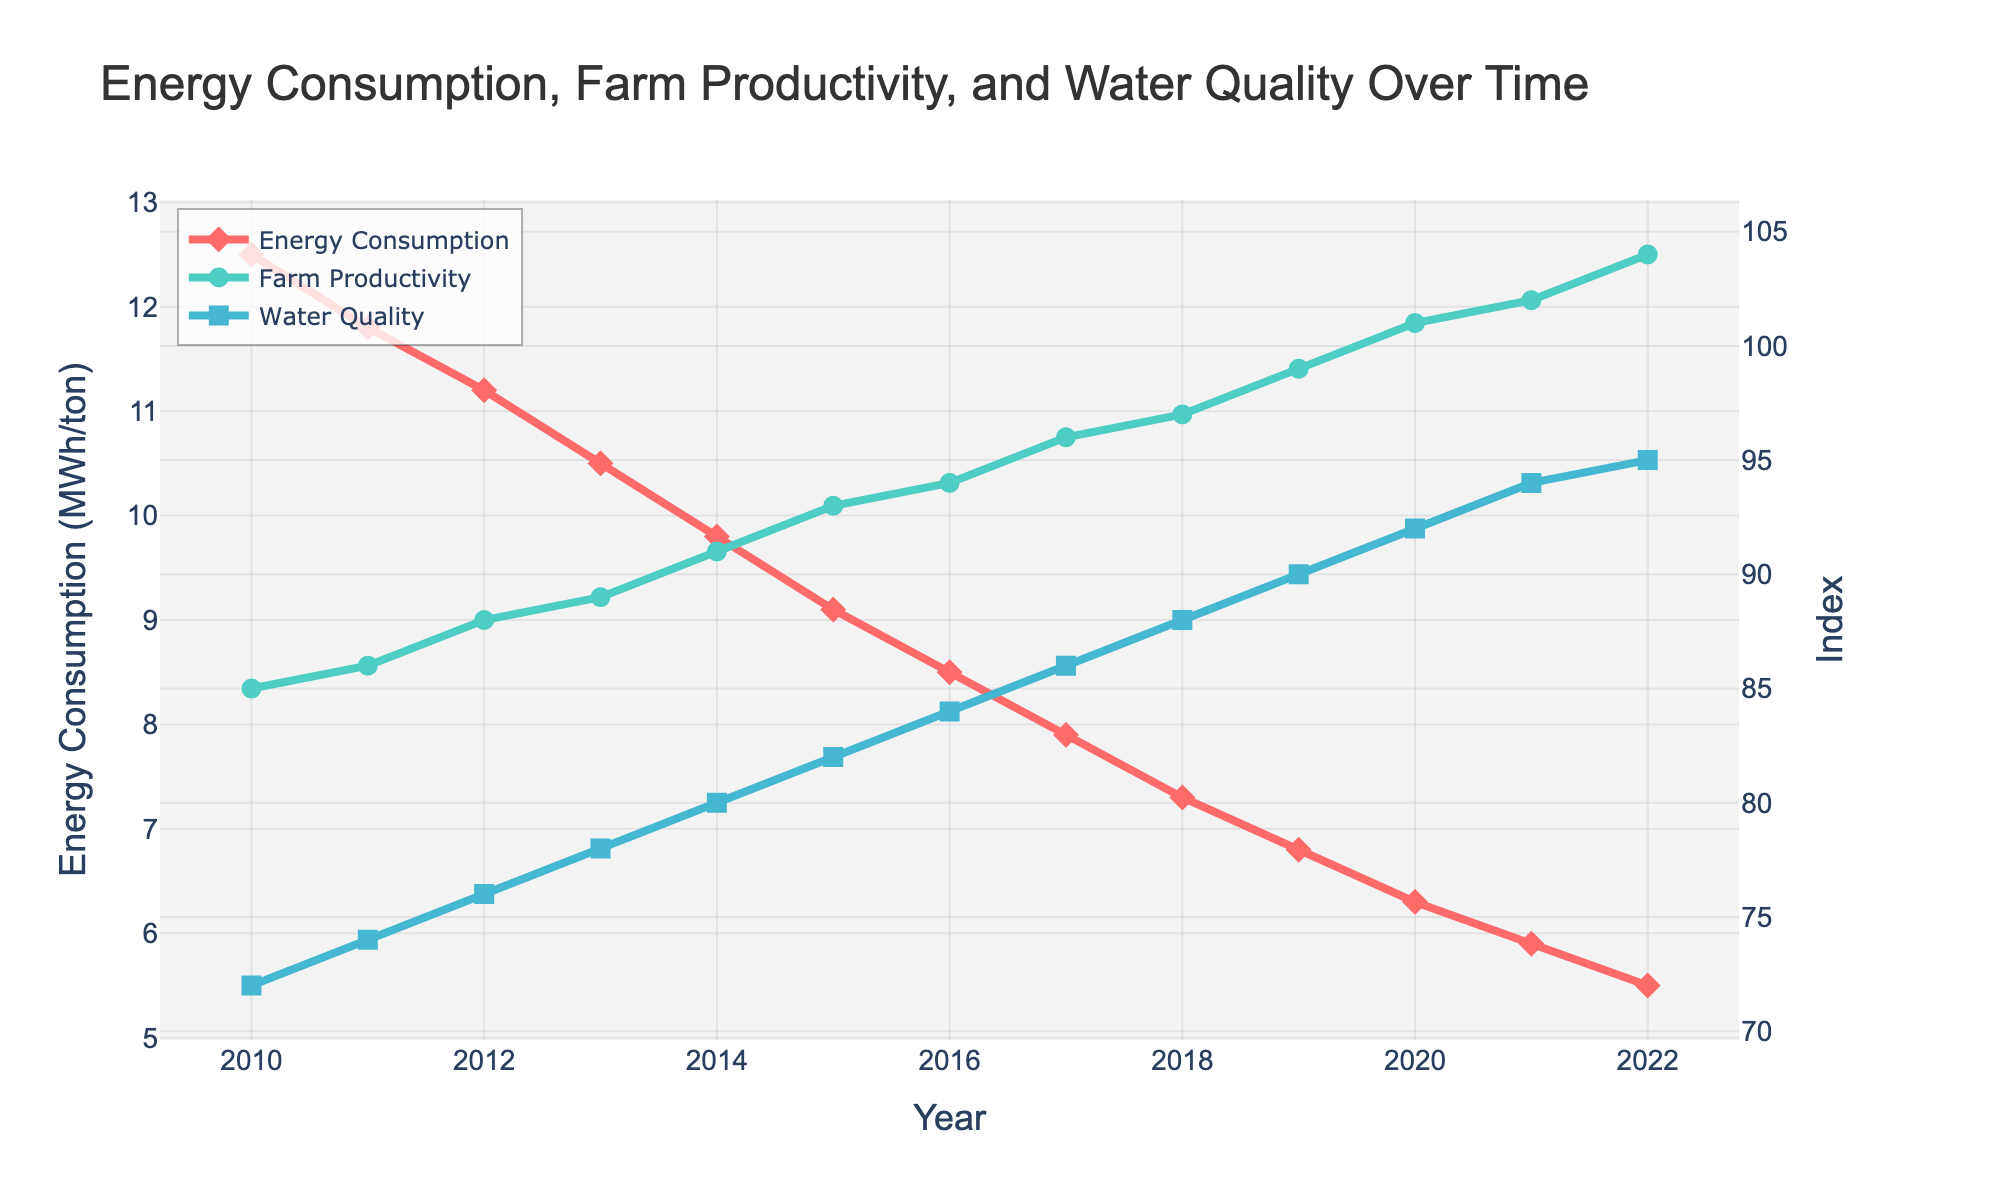What trend do you observe in energy consumption from 2010 to 2022? The energy consumption in MWh per ton decreases steadily from 12.5 in 2010 to 5.5 in 2022. A consistent downward trend is visible.
Answer: A consistent decrease How has farm productivity changed from 2010 to 2022? Farm productivity index increases over the years, starting at 85 in 2010 and rising to 104 by 2022.
Answer: It increased In which year did the local water quality index surpass an index of 90 for the first time? By observing the visual data, the water quality index surpasses 90 for the first time in the year 2019.
Answer: 2019 How does the farm productivity index in 2022 compare to 2010? The farm productivity index increased from 85 in 2010 to 104 in 2022, an increment of 19 points. Calculated as 104 - 85 = 19.
Answer: Higher by 19 points Which year saw the most significant one-year decrease in energy consumption? The year 2014 experienced a significant decrease in energy consumption from 10.5 MWh/ton in 2013 to 9.8 MWh/ton in 2014, which is a reduction of 0.7 MWh/ton.
Answer: 2014 Is there a relationship between decreasing energy consumption and farm productivity over the years? As energy consumption decreases from 12.5 MWh/ton in 2010 to 5.5 MWh/ton in 2022, farm productivity increases from 85 to 104. This inverse relationship indicates that as energy use drops, farm productivity tends to increase.
Answer: Yes, inverse relationship Compare the local water quality index in 2015 and 2018. Which year had a better index? In 2015, the water quality index was 82, whereas in 2018 it was 88. Since 88 is higher than 82, 2018 had a better water quality index.
Answer: 2018 What common pattern can you identify among the three indices over the years? All three indices (energy consumption, farm productivity, and water quality) show an improvement over the years. Energy consumption decreases while farm productivity and water quality indices increase.
Answer: Improving trends 